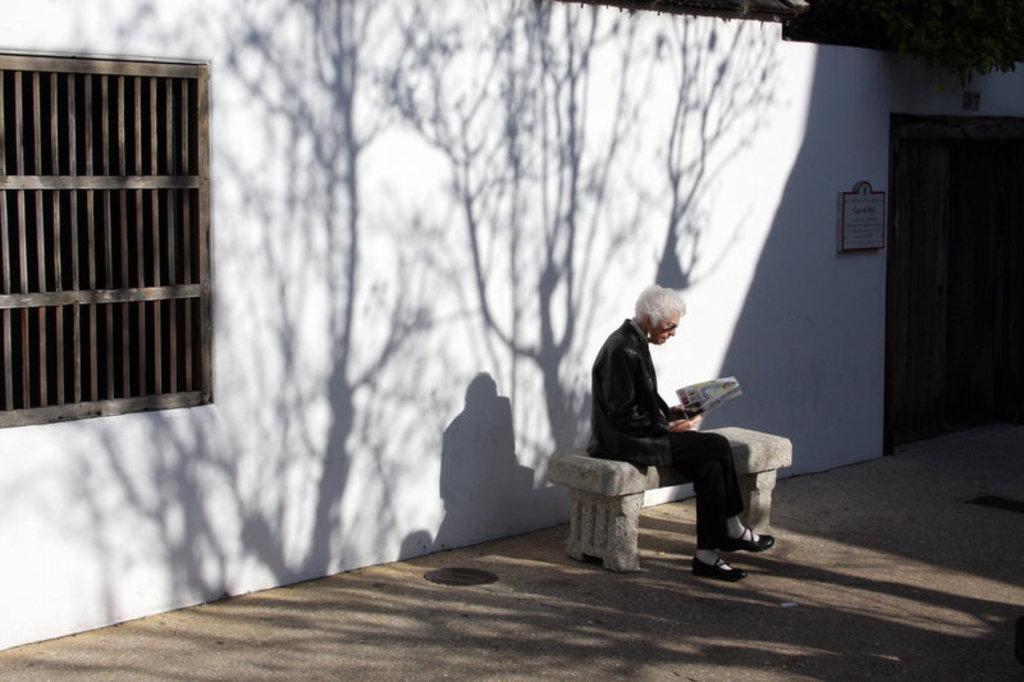In one or two sentences, can you explain what this image depicts? In this image we can see a person on the bench and holding a book. In the background there is a building and we can see a door and a window. 